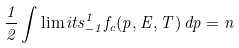<formula> <loc_0><loc_0><loc_500><loc_500>\frac { 1 } { 2 } \int \lim i t s _ { - 1 } ^ { 1 } f _ { c } ( p , E , T ) \, d p = n</formula> 